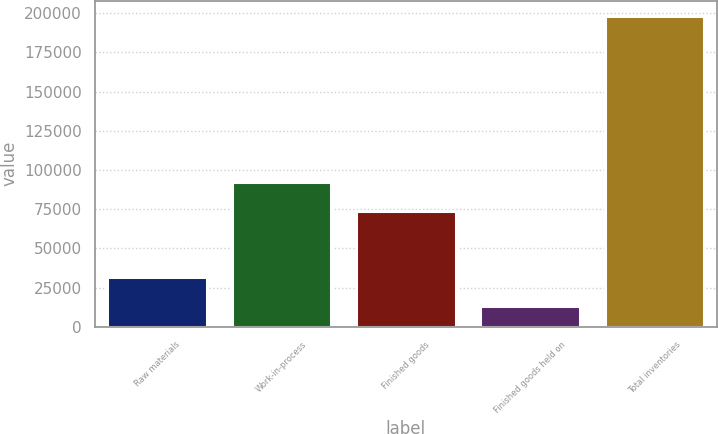Convert chart to OTSL. <chart><loc_0><loc_0><loc_500><loc_500><bar_chart><fcel>Raw materials<fcel>Work-in-process<fcel>Finished goods<fcel>Finished goods held on<fcel>Total inventories<nl><fcel>31863.9<fcel>92601<fcel>73633<fcel>13384<fcel>198183<nl></chart> 